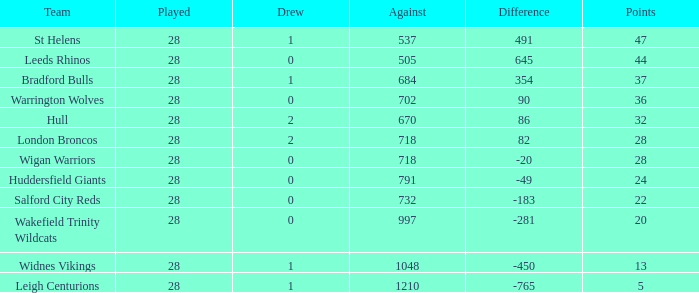I'm looking to parse the entire table for insights. Could you assist me with that? {'header': ['Team', 'Played', 'Drew', 'Against', 'Difference', 'Points'], 'rows': [['St Helens', '28', '1', '537', '491', '47'], ['Leeds Rhinos', '28', '0', '505', '645', '44'], ['Bradford Bulls', '28', '1', '684', '354', '37'], ['Warrington Wolves', '28', '0', '702', '90', '36'], ['Hull', '28', '2', '670', '86', '32'], ['London Broncos', '28', '2', '718', '82', '28'], ['Wigan Warriors', '28', '0', '718', '-20', '28'], ['Huddersfield Giants', '28', '0', '791', '-49', '24'], ['Salford City Reds', '28', '0', '732', '-183', '22'], ['Wakefield Trinity Wildcats', '28', '0', '997', '-281', '20'], ['Widnes Vikings', '28', '1', '1048', '-450', '13'], ['Leigh Centurions', '28', '1', '1210', '-765', '5']]} What is the mean score for a team that has 4 losses and has participated in over 28 matches? None. 